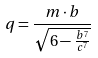<formula> <loc_0><loc_0><loc_500><loc_500>q = \frac { m \cdot b } { \sqrt { 6 - \frac { b ^ { 7 } } { c ^ { 7 } } } }</formula> 